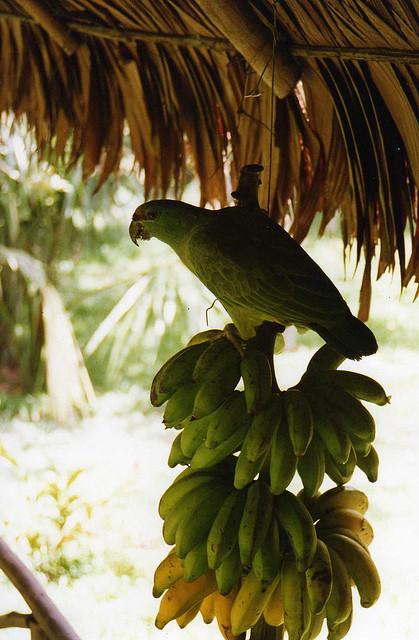Is it snowing?
Give a very brief answer. No. What type of roof is shown?
Answer briefly. Thatch. Is this picture manipulated?
Give a very brief answer. No. Does this type of bird eat bananas?
Write a very short answer. Yes. 